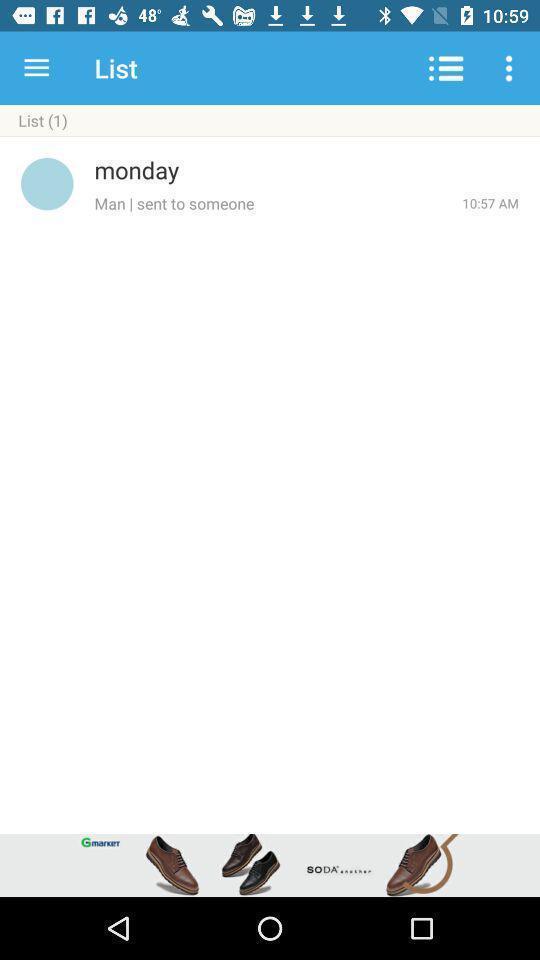Give me a narrative description of this picture. Screen displaying the page of a social app. 